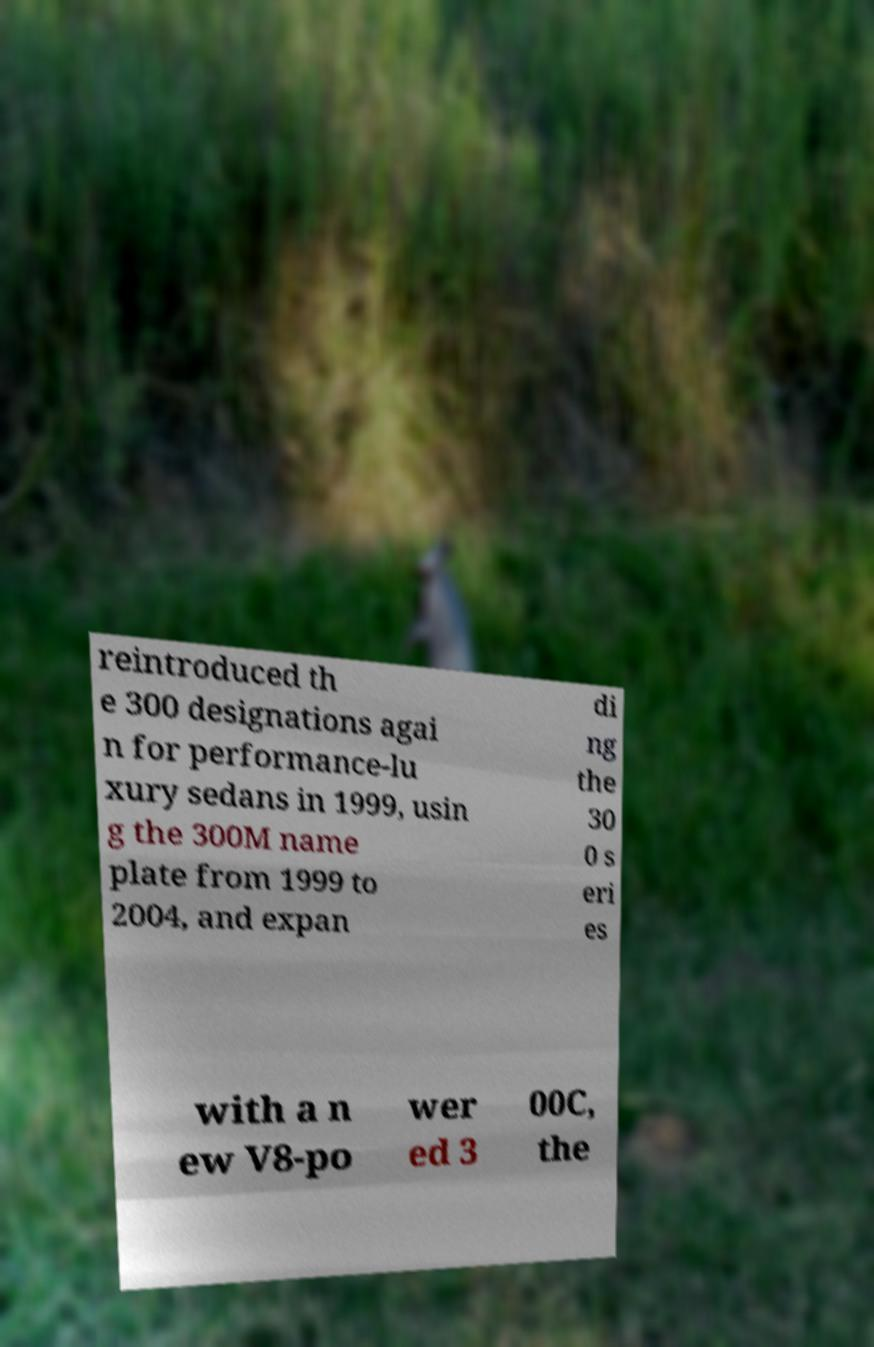Please read and relay the text visible in this image. What does it say? reintroduced th e 300 designations agai n for performance-lu xury sedans in 1999, usin g the 300M name plate from 1999 to 2004, and expan di ng the 30 0 s eri es with a n ew V8-po wer ed 3 00C, the 